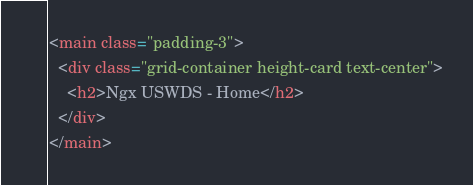<code> <loc_0><loc_0><loc_500><loc_500><_HTML_><main class="padding-3">
  <div class="grid-container height-card text-center">
    <h2>Ngx USWDS - Home</h2>
  </div>
</main>
</code> 